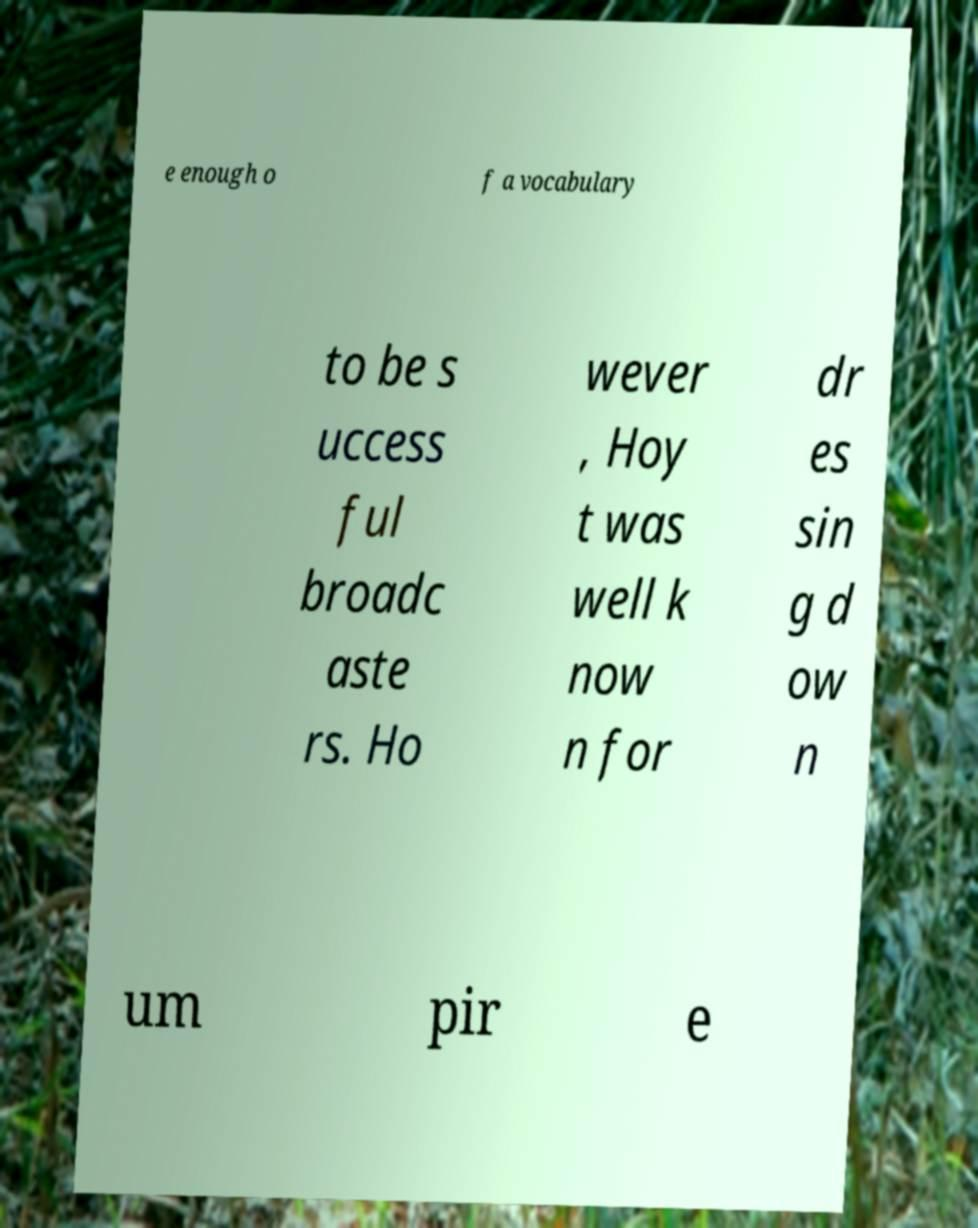Can you read and provide the text displayed in the image?This photo seems to have some interesting text. Can you extract and type it out for me? e enough o f a vocabulary to be s uccess ful broadc aste rs. Ho wever , Hoy t was well k now n for dr es sin g d ow n um pir e 